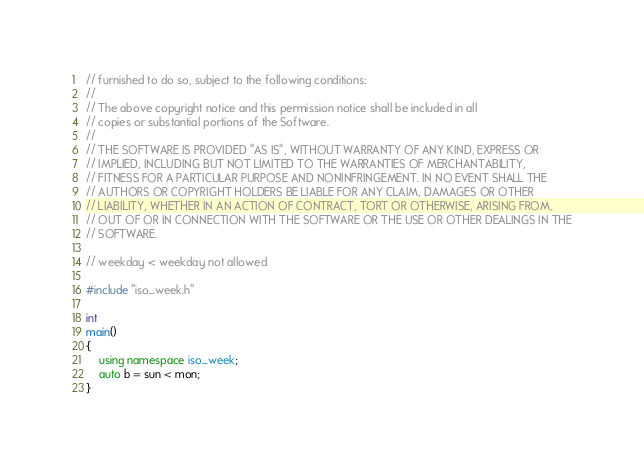Convert code to text. <code><loc_0><loc_0><loc_500><loc_500><_C++_>// furnished to do so, subject to the following conditions:
//
// The above copyright notice and this permission notice shall be included in all
// copies or substantial portions of the Software.
//
// THE SOFTWARE IS PROVIDED "AS IS", WITHOUT WARRANTY OF ANY KIND, EXPRESS OR
// IMPLIED, INCLUDING BUT NOT LIMITED TO THE WARRANTIES OF MERCHANTABILITY,
// FITNESS FOR A PARTICULAR PURPOSE AND NONINFRINGEMENT. IN NO EVENT SHALL THE
// AUTHORS OR COPYRIGHT HOLDERS BE LIABLE FOR ANY CLAIM, DAMAGES OR OTHER
// LIABILITY, WHETHER IN AN ACTION OF CONTRACT, TORT OR OTHERWISE, ARISING FROM,
// OUT OF OR IN CONNECTION WITH THE SOFTWARE OR THE USE OR OTHER DEALINGS IN THE
// SOFTWARE.

// weekday < weekday not allowed

#include "iso_week.h"

int
main()
{
    using namespace iso_week;
    auto b = sun < mon;
}
</code> 